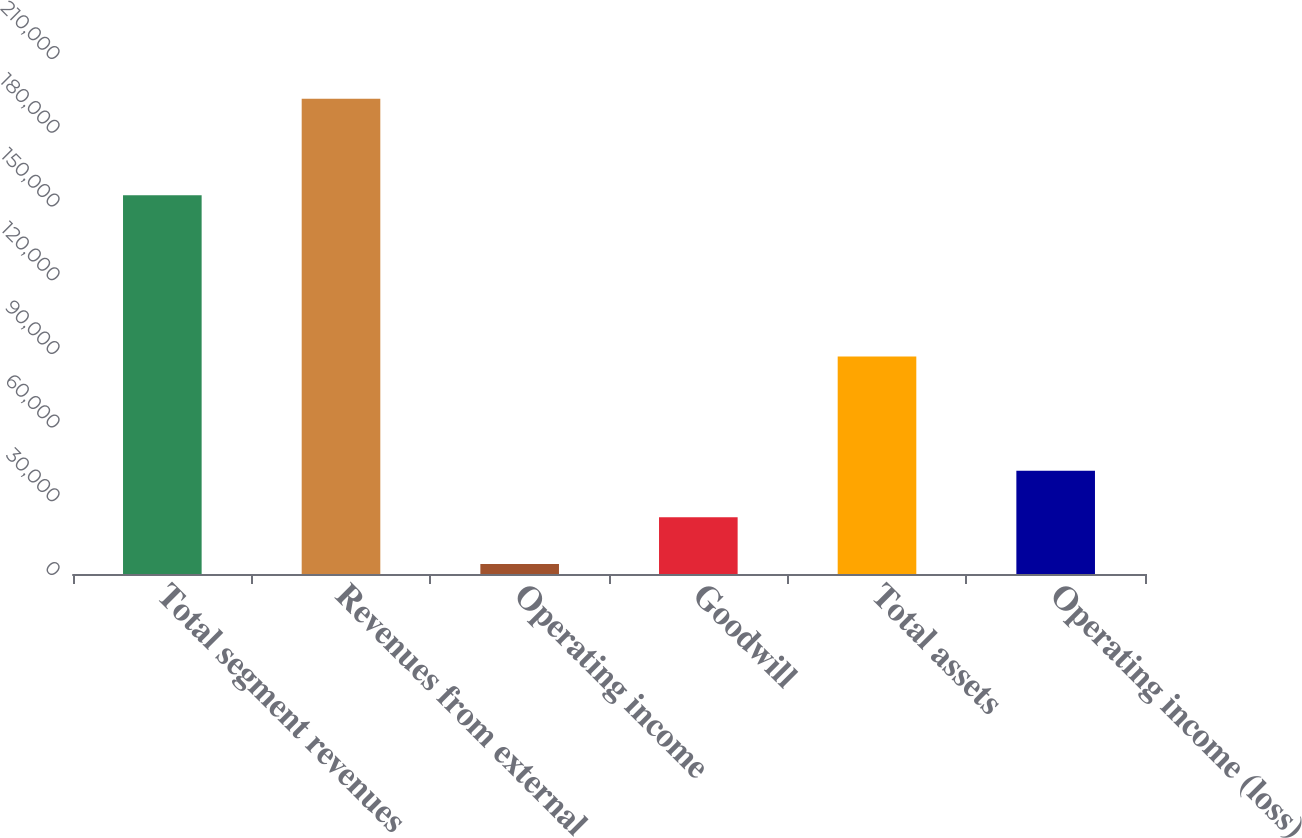Convert chart. <chart><loc_0><loc_0><loc_500><loc_500><bar_chart><fcel>Total segment revenues<fcel>Revenues from external<fcel>Operating income<fcel>Goodwill<fcel>Total assets<fcel>Operating income (loss)<nl><fcel>154121<fcel>193452<fcel>4120<fcel>23053.2<fcel>88469<fcel>41986.4<nl></chart> 